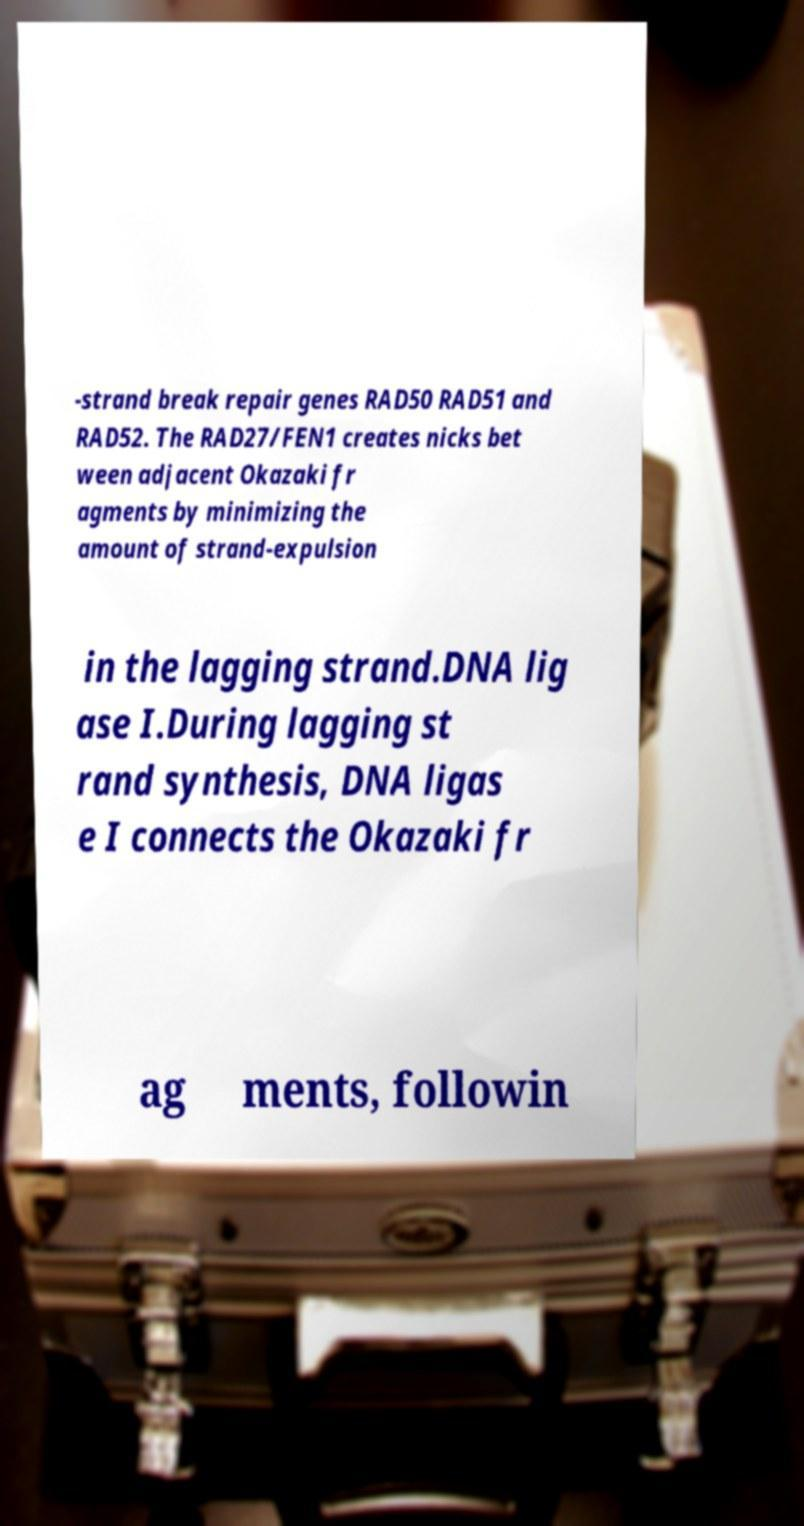I need the written content from this picture converted into text. Can you do that? -strand break repair genes RAD50 RAD51 and RAD52. The RAD27/FEN1 creates nicks bet ween adjacent Okazaki fr agments by minimizing the amount of strand-expulsion in the lagging strand.DNA lig ase I.During lagging st rand synthesis, DNA ligas e I connects the Okazaki fr ag ments, followin 